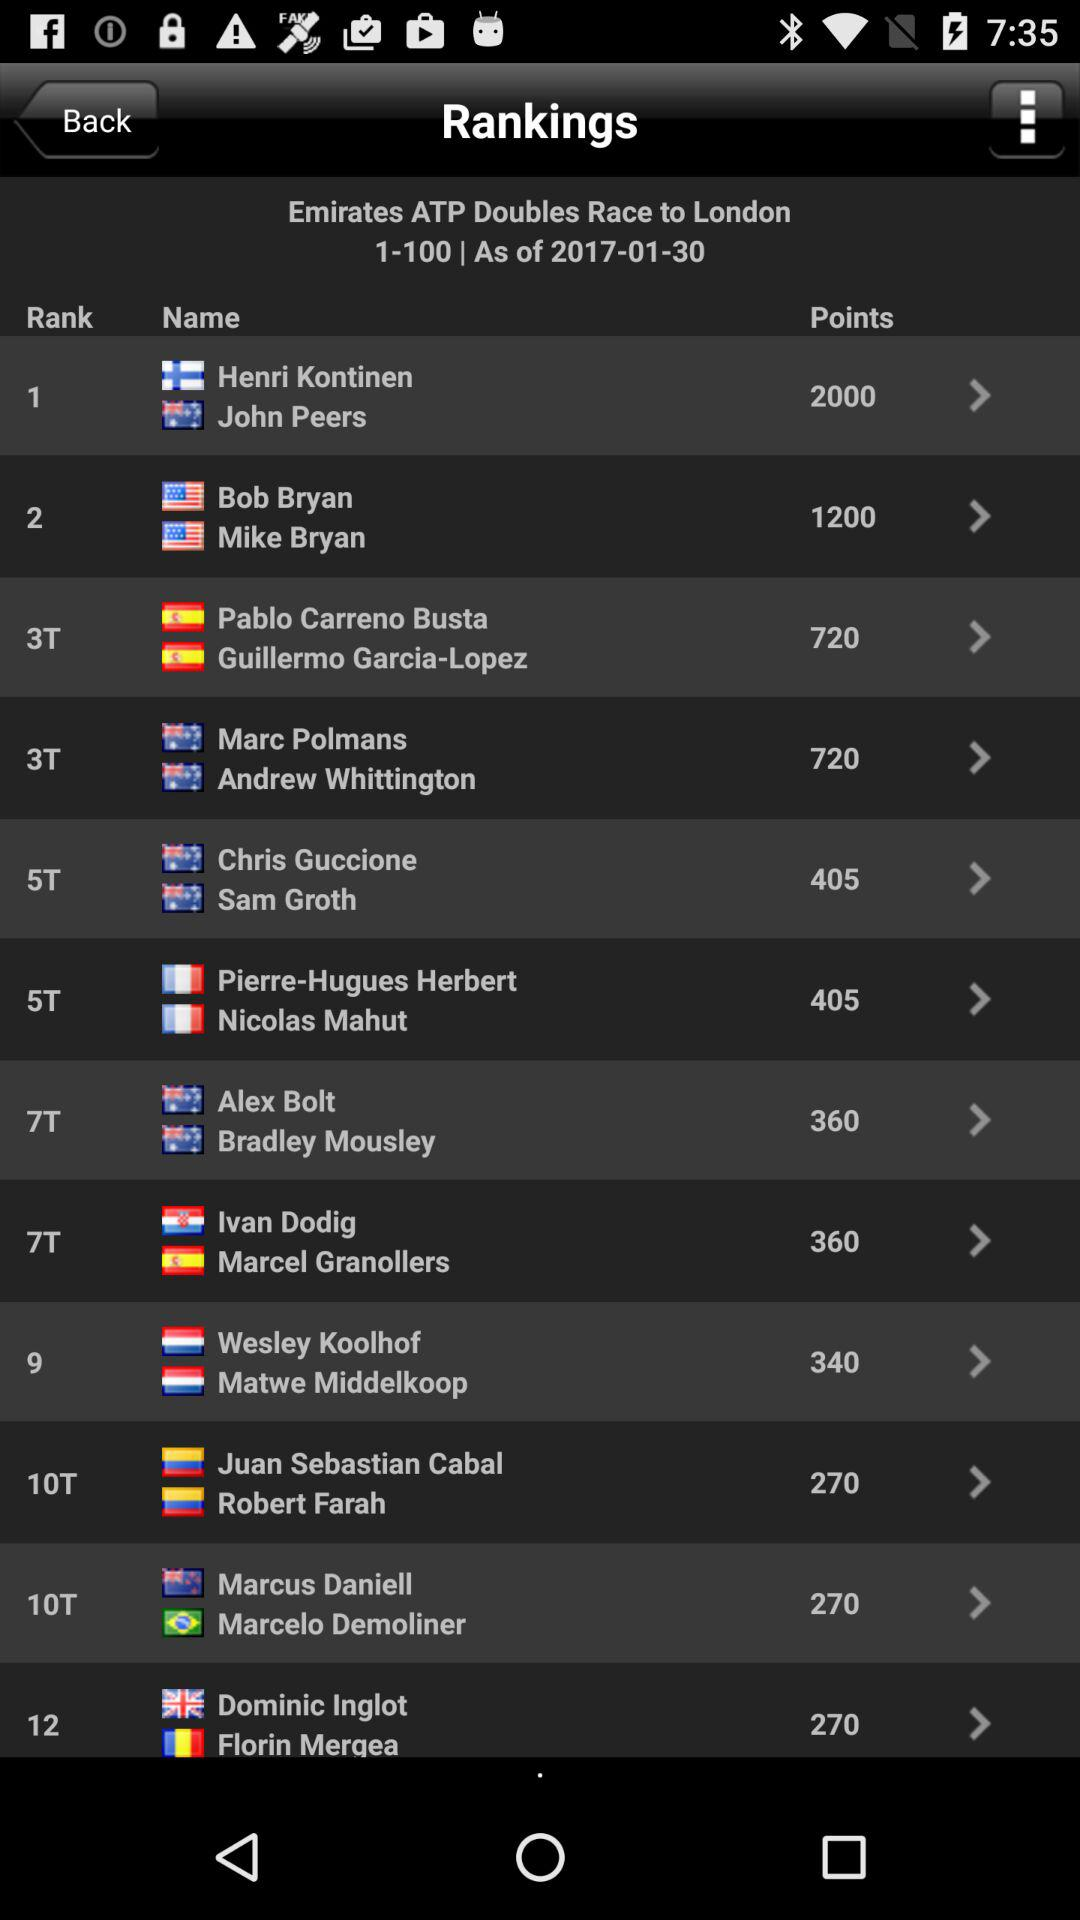What are the points of Bob Bryan and Mike Bryan? There are 1200 points. 